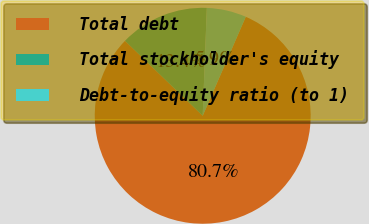<chart> <loc_0><loc_0><loc_500><loc_500><pie_chart><fcel>Total debt<fcel>Total stockholder's equity<fcel>Debt-to-equity ratio (to 1)<nl><fcel>80.68%<fcel>13.4%<fcel>5.92%<nl></chart> 